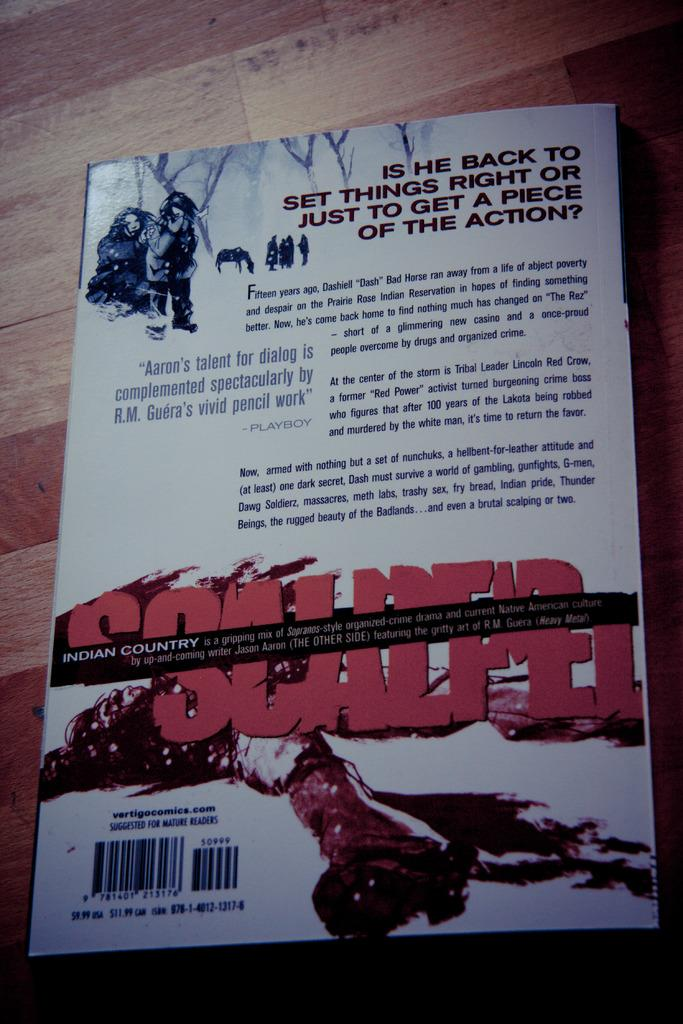<image>
Provide a brief description of the given image. the back cover of a book titled soldier indian country. 